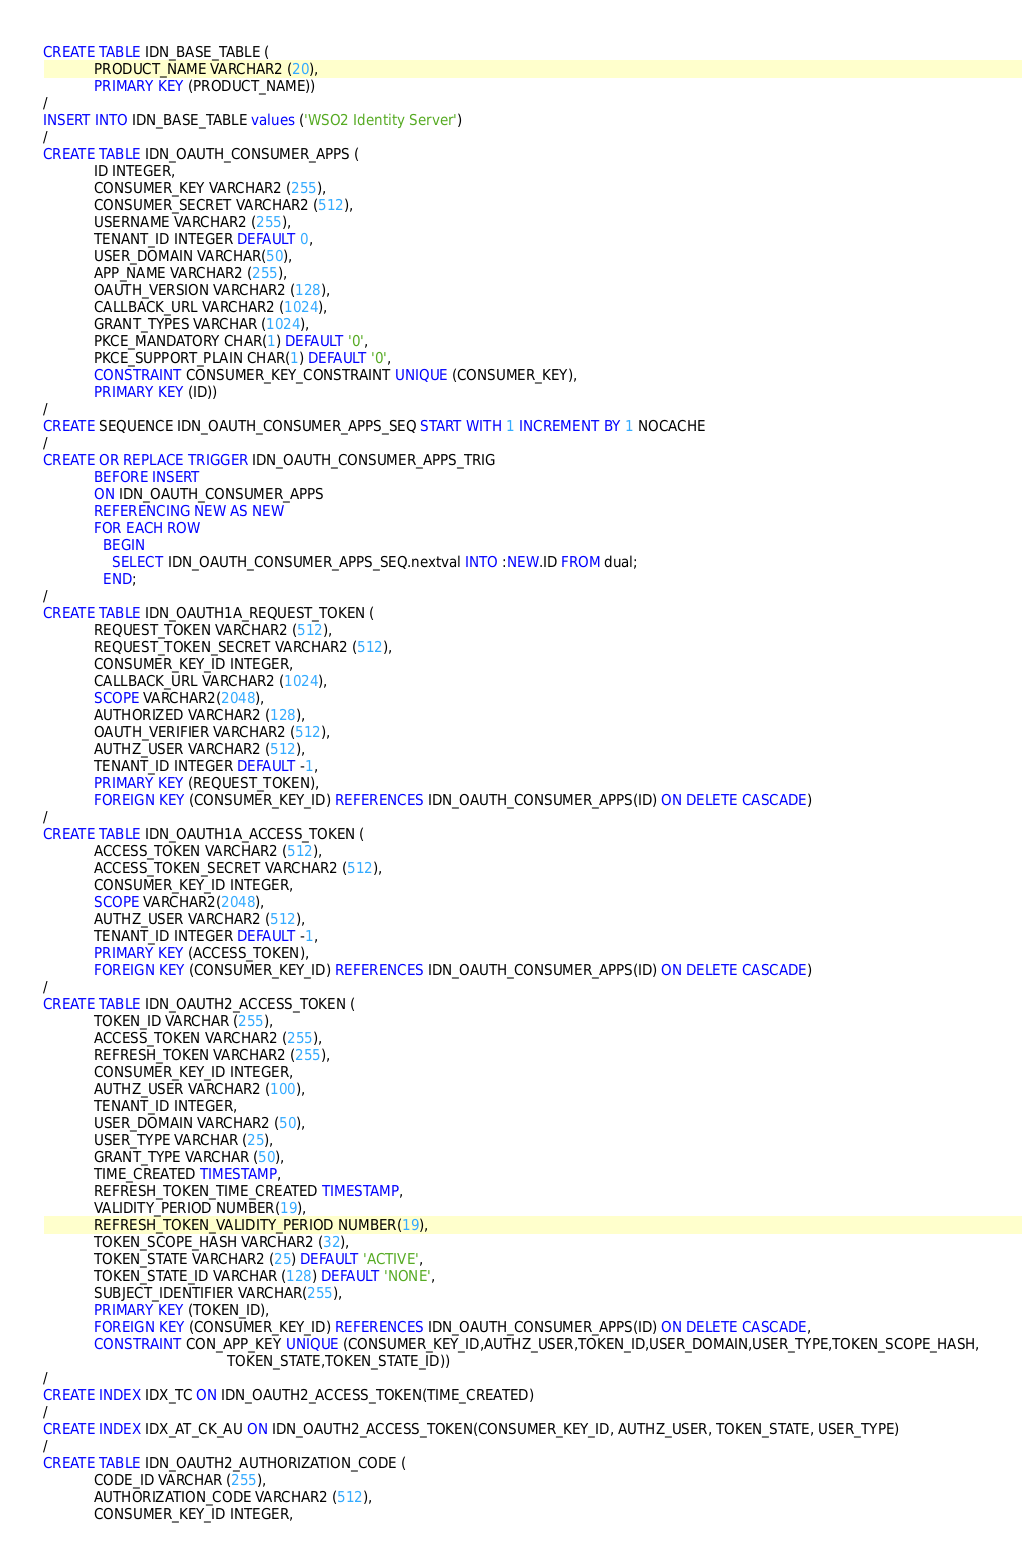<code> <loc_0><loc_0><loc_500><loc_500><_SQL_>CREATE TABLE IDN_BASE_TABLE (
            PRODUCT_NAME VARCHAR2 (20),
            PRIMARY KEY (PRODUCT_NAME))
/
INSERT INTO IDN_BASE_TABLE values ('WSO2 Identity Server')
/
CREATE TABLE IDN_OAUTH_CONSUMER_APPS (
            ID INTEGER,
            CONSUMER_KEY VARCHAR2 (255),
            CONSUMER_SECRET VARCHAR2 (512),
            USERNAME VARCHAR2 (255),
            TENANT_ID INTEGER DEFAULT 0,
            USER_DOMAIN VARCHAR(50),
            APP_NAME VARCHAR2 (255),
            OAUTH_VERSION VARCHAR2 (128),
            CALLBACK_URL VARCHAR2 (1024),
            GRANT_TYPES VARCHAR (1024),
            PKCE_MANDATORY CHAR(1) DEFAULT '0',
            PKCE_SUPPORT_PLAIN CHAR(1) DEFAULT '0',
            CONSTRAINT CONSUMER_KEY_CONSTRAINT UNIQUE (CONSUMER_KEY),
            PRIMARY KEY (ID))
/
CREATE SEQUENCE IDN_OAUTH_CONSUMER_APPS_SEQ START WITH 1 INCREMENT BY 1 NOCACHE
/
CREATE OR REPLACE TRIGGER IDN_OAUTH_CONSUMER_APPS_TRIG
            BEFORE INSERT
            ON IDN_OAUTH_CONSUMER_APPS
            REFERENCING NEW AS NEW
            FOR EACH ROW
              BEGIN
                SELECT IDN_OAUTH_CONSUMER_APPS_SEQ.nextval INTO :NEW.ID FROM dual;
              END;
/
CREATE TABLE IDN_OAUTH1A_REQUEST_TOKEN (
            REQUEST_TOKEN VARCHAR2 (512),
            REQUEST_TOKEN_SECRET VARCHAR2 (512),
            CONSUMER_KEY_ID INTEGER,
            CALLBACK_URL VARCHAR2 (1024),
            SCOPE VARCHAR2(2048),
            AUTHORIZED VARCHAR2 (128),
            OAUTH_VERIFIER VARCHAR2 (512),
            AUTHZ_USER VARCHAR2 (512),
            TENANT_ID INTEGER DEFAULT -1,
            PRIMARY KEY (REQUEST_TOKEN),
            FOREIGN KEY (CONSUMER_KEY_ID) REFERENCES IDN_OAUTH_CONSUMER_APPS(ID) ON DELETE CASCADE)
/
CREATE TABLE IDN_OAUTH1A_ACCESS_TOKEN (
            ACCESS_TOKEN VARCHAR2 (512),
            ACCESS_TOKEN_SECRET VARCHAR2 (512),
            CONSUMER_KEY_ID INTEGER,
            SCOPE VARCHAR2(2048),
            AUTHZ_USER VARCHAR2 (512),
            TENANT_ID INTEGER DEFAULT -1,
            PRIMARY KEY (ACCESS_TOKEN),
            FOREIGN KEY (CONSUMER_KEY_ID) REFERENCES IDN_OAUTH_CONSUMER_APPS(ID) ON DELETE CASCADE)
/
CREATE TABLE IDN_OAUTH2_ACCESS_TOKEN (
            TOKEN_ID VARCHAR (255),
            ACCESS_TOKEN VARCHAR2 (255),
            REFRESH_TOKEN VARCHAR2 (255),
            CONSUMER_KEY_ID INTEGER,
            AUTHZ_USER VARCHAR2 (100),
            TENANT_ID INTEGER,
            USER_DOMAIN VARCHAR2 (50),
            USER_TYPE VARCHAR (25),
            GRANT_TYPE VARCHAR (50),
            TIME_CREATED TIMESTAMP,
            REFRESH_TOKEN_TIME_CREATED TIMESTAMP,
            VALIDITY_PERIOD NUMBER(19),
            REFRESH_TOKEN_VALIDITY_PERIOD NUMBER(19),
            TOKEN_SCOPE_HASH VARCHAR2 (32),
            TOKEN_STATE VARCHAR2 (25) DEFAULT 'ACTIVE',
            TOKEN_STATE_ID VARCHAR (128) DEFAULT 'NONE',
            SUBJECT_IDENTIFIER VARCHAR(255),
            PRIMARY KEY (TOKEN_ID),
            FOREIGN KEY (CONSUMER_KEY_ID) REFERENCES IDN_OAUTH_CONSUMER_APPS(ID) ON DELETE CASCADE,
            CONSTRAINT CON_APP_KEY UNIQUE (CONSUMER_KEY_ID,AUTHZ_USER,TOKEN_ID,USER_DOMAIN,USER_TYPE,TOKEN_SCOPE_HASH,
                                           TOKEN_STATE,TOKEN_STATE_ID))
/
CREATE INDEX IDX_TC ON IDN_OAUTH2_ACCESS_TOKEN(TIME_CREATED)
/
CREATE INDEX IDX_AT_CK_AU ON IDN_OAUTH2_ACCESS_TOKEN(CONSUMER_KEY_ID, AUTHZ_USER, TOKEN_STATE, USER_TYPE)
/
CREATE TABLE IDN_OAUTH2_AUTHORIZATION_CODE (
            CODE_ID VARCHAR (255),
            AUTHORIZATION_CODE VARCHAR2 (512),
            CONSUMER_KEY_ID INTEGER,</code> 